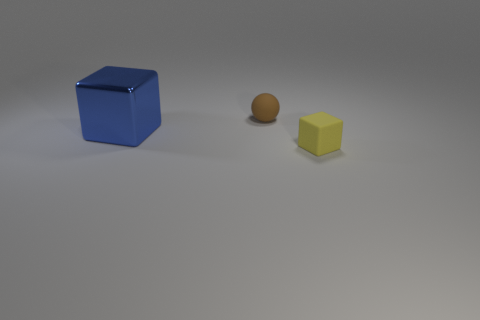Add 2 small yellow things. How many objects exist? 5 Subtract all spheres. How many objects are left? 2 Add 2 blue things. How many blue things are left? 3 Add 2 small rubber blocks. How many small rubber blocks exist? 3 Subtract 0 green spheres. How many objects are left? 3 Subtract all small yellow things. Subtract all large gray rubber balls. How many objects are left? 2 